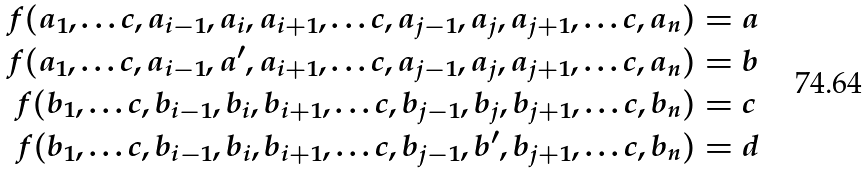Convert formula to latex. <formula><loc_0><loc_0><loc_500><loc_500>f ( a _ { 1 } , \dots c , a _ { i - 1 } , a _ { i } , a _ { i + 1 } , \dots c , a _ { j - 1 } , a _ { j } , a _ { j + 1 } , \dots c , a _ { n } ) & = a \\ f ( a _ { 1 } , \dots c , a _ { i - 1 } , a ^ { \prime } , a _ { i + 1 } , \dots c , a _ { j - 1 } , a _ { j } , a _ { j + 1 } , \dots c , a _ { n } ) & = b \\ f ( b _ { 1 } , \dots c , b _ { i - 1 } , b _ { i } , b _ { i + 1 } , \dots c , b _ { j - 1 } , b _ { j } , b _ { j + 1 } , \dots c , b _ { n } ) & = c \\ f ( b _ { 1 } , \dots c , b _ { i - 1 } , b _ { i } , b _ { i + 1 } , \dots c , b _ { j - 1 } , b ^ { \prime } , b _ { j + 1 } , \dots c , b _ { n } ) & = d</formula> 